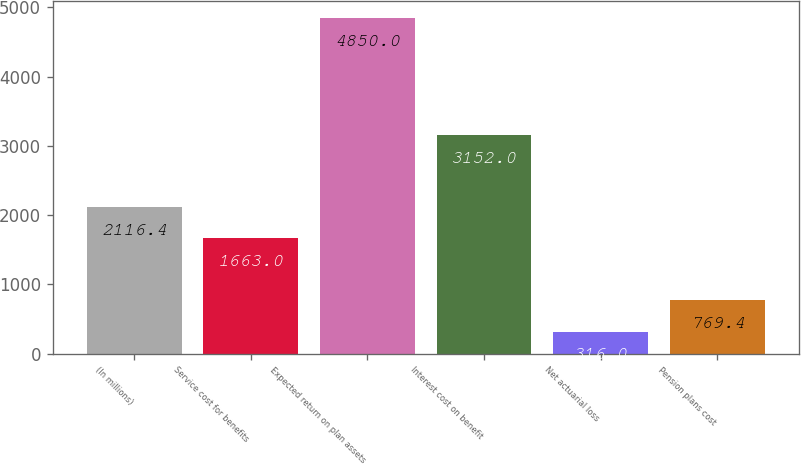Convert chart to OTSL. <chart><loc_0><loc_0><loc_500><loc_500><bar_chart><fcel>(In millions)<fcel>Service cost for benefits<fcel>Expected return on plan assets<fcel>Interest cost on benefit<fcel>Net actuarial loss<fcel>Pension plans cost<nl><fcel>2116.4<fcel>1663<fcel>4850<fcel>3152<fcel>316<fcel>769.4<nl></chart> 